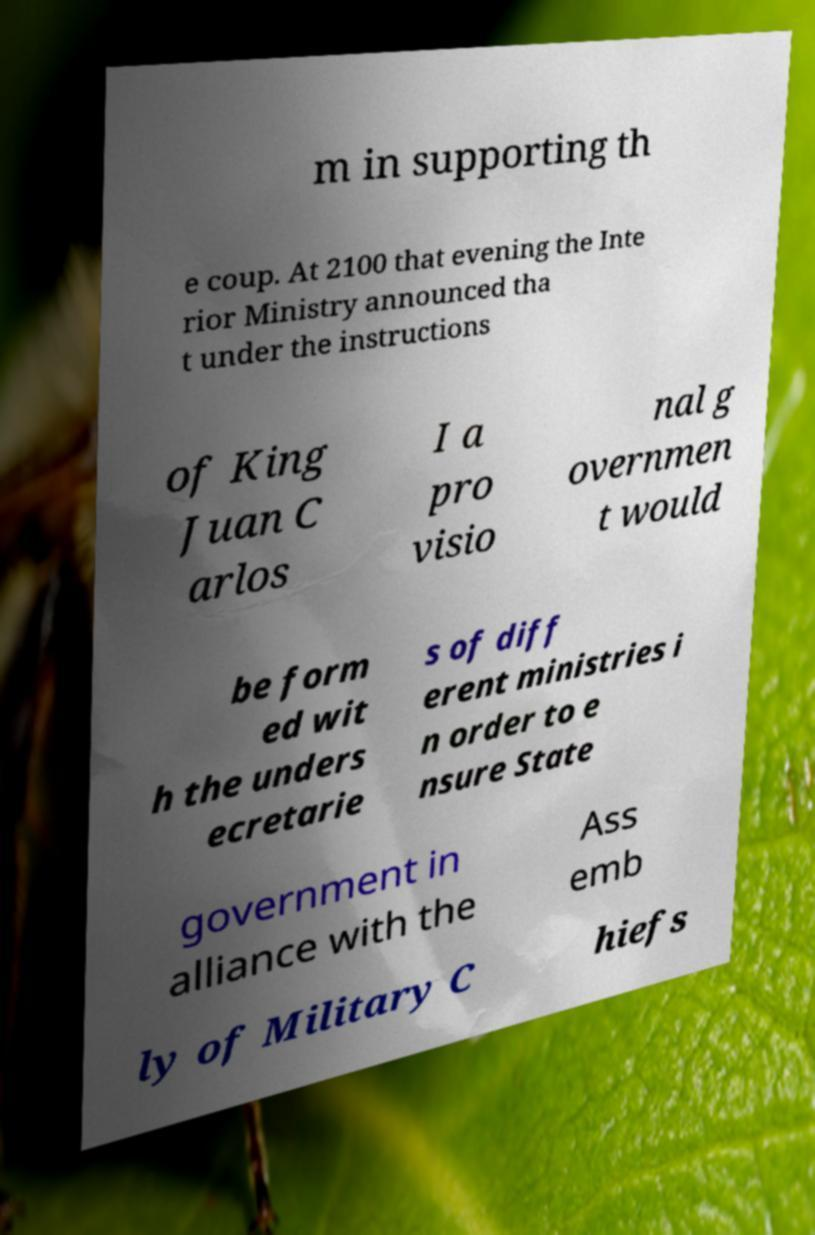Could you assist in decoding the text presented in this image and type it out clearly? m in supporting th e coup. At 2100 that evening the Inte rior Ministry announced tha t under the instructions of King Juan C arlos I a pro visio nal g overnmen t would be form ed wit h the unders ecretarie s of diff erent ministries i n order to e nsure State government in alliance with the Ass emb ly of Military C hiefs 